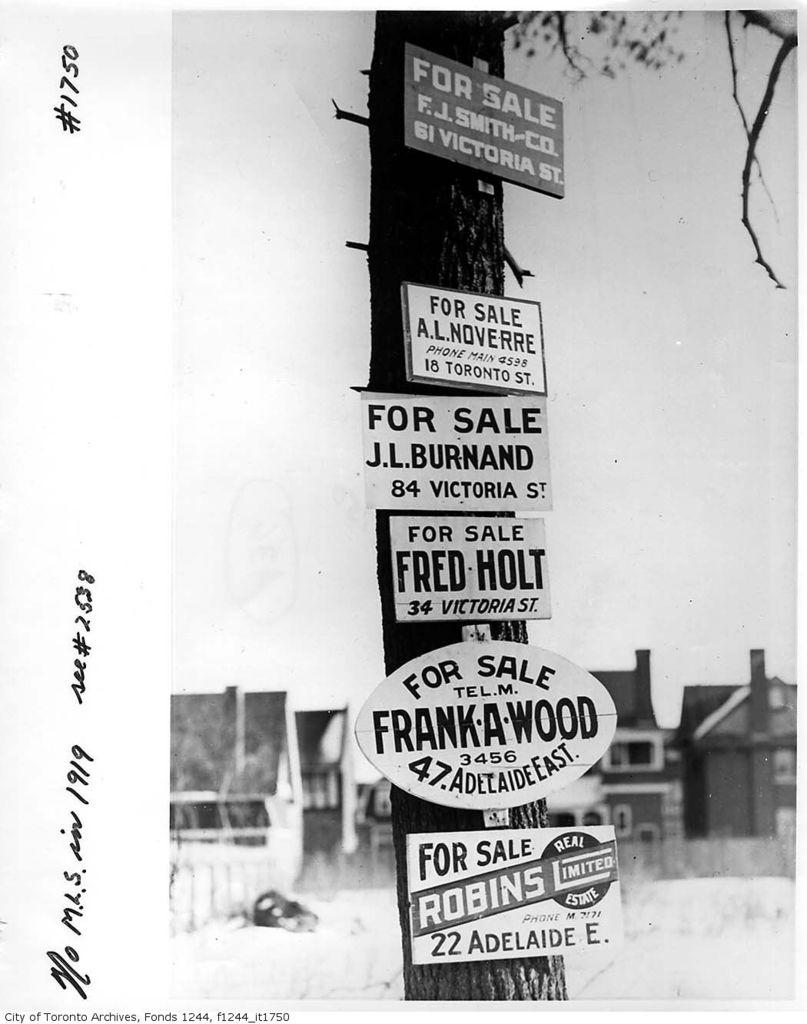What is featured on the poster in the image? The poster contains a tree. Are there any other elements on the poster besides the tree? Yes, there are boards on the poster. Is there any text present in the image? Yes, there is text on the image. Can you see any animals from the zoo in the image? There is no zoo or animals present in the image; it features a poster with a tree and text. Is there a hill visible in the image? There is no hill present in the image. 